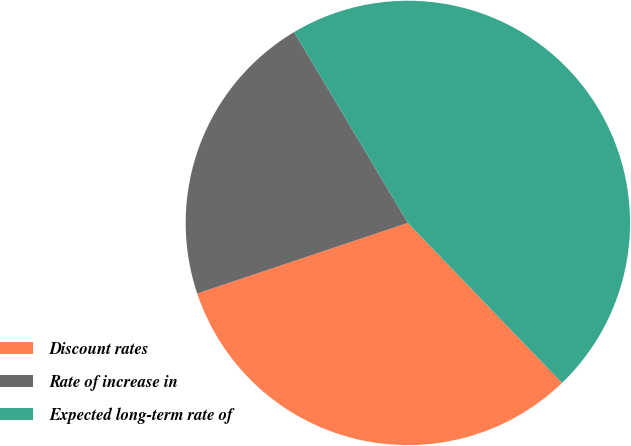Convert chart to OTSL. <chart><loc_0><loc_0><loc_500><loc_500><pie_chart><fcel>Discount rates<fcel>Rate of increase in<fcel>Expected long-term rate of<nl><fcel>32.06%<fcel>21.59%<fcel>46.35%<nl></chart> 